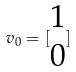Convert formula to latex. <formula><loc_0><loc_0><loc_500><loc_500>v _ { 0 } = [ \begin{matrix} 1 \\ 0 \end{matrix} ]</formula> 